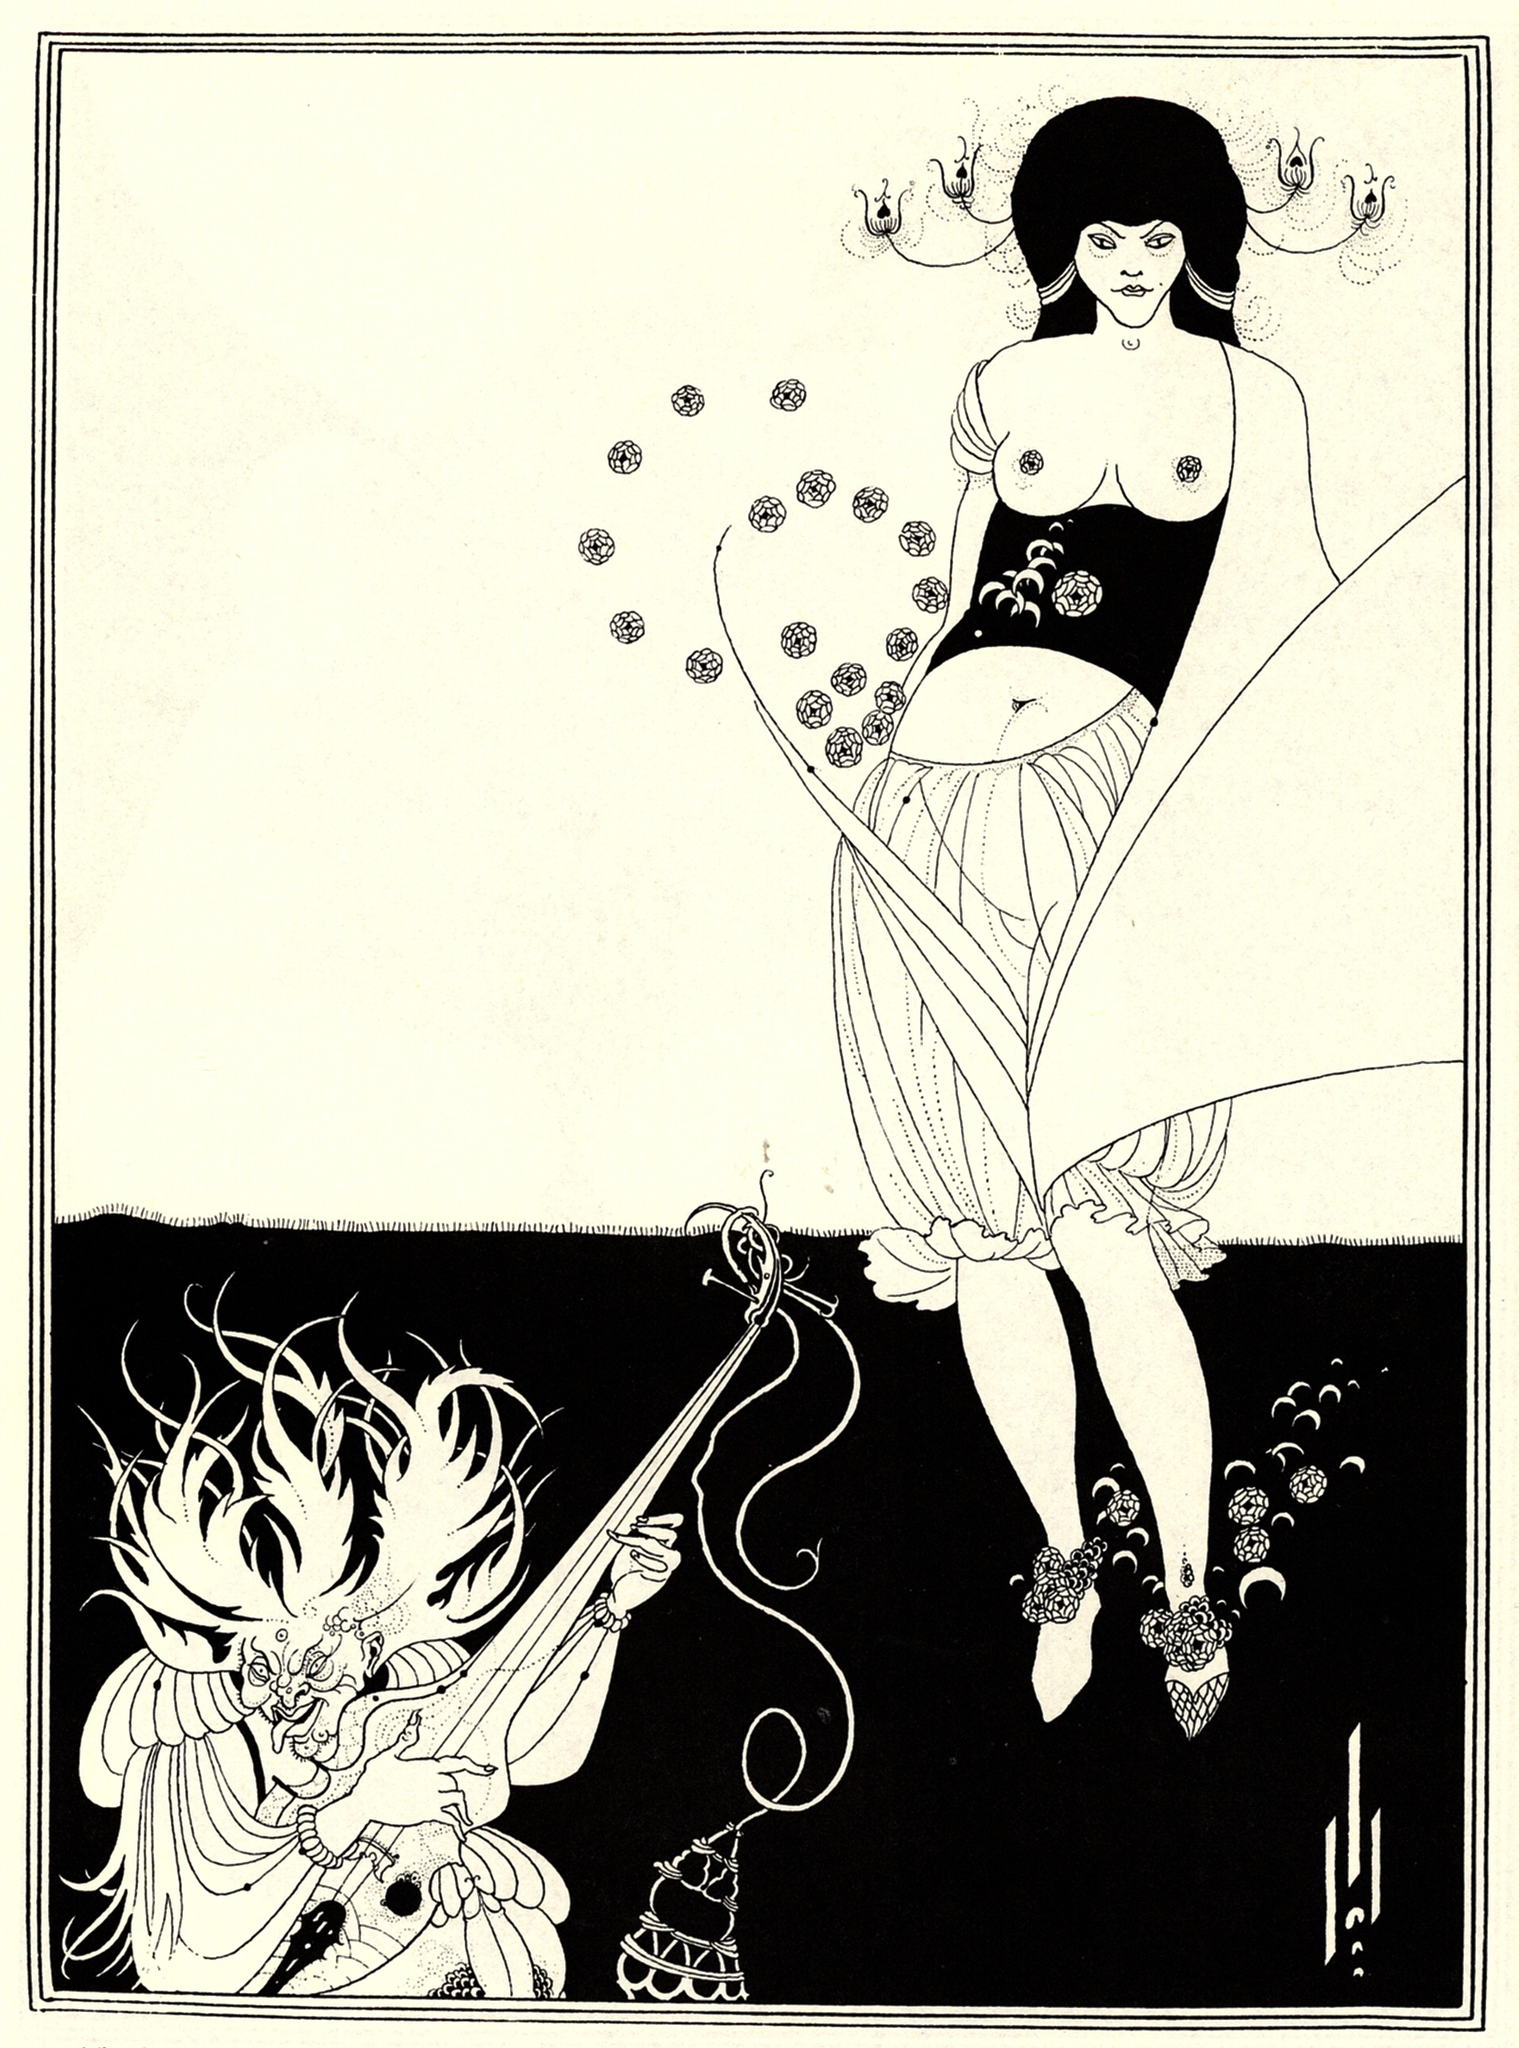What's happening in the scene? The image is a striking example of the Art Nouveau style, emphasized by its flowing lines and natural motifs. The scene features a woman and a dragon as its central figures. The woman, standing on the right, is adorned in a dress sprinkled with a floral pattern, her body facing forward while her head is turned to the left in a profile view. She holds a long, thin object toward the dragon in her right hand.

On the left side, the dragon is illustrated with an equal attention to detail. Facing forward with its head turned to the right, the dragon adds a sense of drama by holding a censer in its left hand and a sword in its right. Both figures share a floral motif, uniting them artistically. The background is a stark white, which contrasts against the detailed central figures, while the black border of lines and dots further frames the scene. This illustration masterfully blends natural and fantastical elements reminiscent of Art Nouveau aesthetics. 